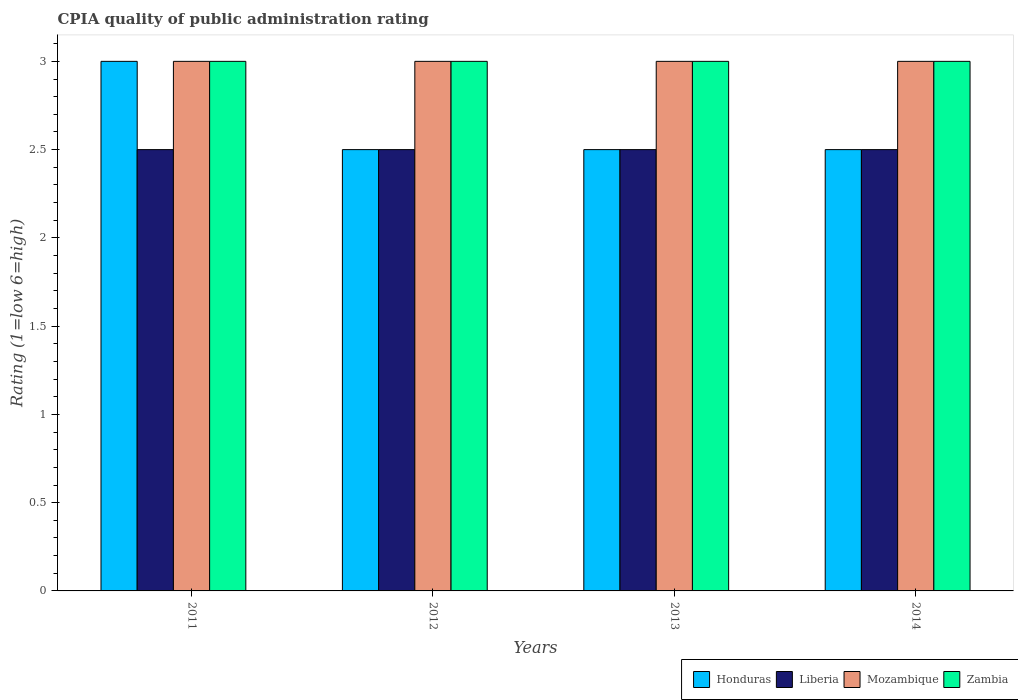How many groups of bars are there?
Your answer should be very brief. 4. Are the number of bars per tick equal to the number of legend labels?
Your answer should be compact. Yes. How many bars are there on the 1st tick from the right?
Your response must be concise. 4. What is the label of the 4th group of bars from the left?
Give a very brief answer. 2014. Across all years, what is the maximum CPIA rating in Honduras?
Provide a succinct answer. 3. Across all years, what is the minimum CPIA rating in Zambia?
Your response must be concise. 3. In which year was the CPIA rating in Liberia maximum?
Ensure brevity in your answer.  2011. In which year was the CPIA rating in Mozambique minimum?
Offer a very short reply. 2011. What is the total CPIA rating in Zambia in the graph?
Give a very brief answer. 12. What is the difference between the CPIA rating in Liberia in 2012 and that in 2014?
Offer a very short reply. 0. What is the difference between the CPIA rating in Honduras in 2014 and the CPIA rating in Mozambique in 2012?
Your answer should be very brief. -0.5. In how many years, is the CPIA rating in Mozambique greater than 2.9?
Ensure brevity in your answer.  4. Is the difference between the CPIA rating in Honduras in 2012 and 2013 greater than the difference between the CPIA rating in Liberia in 2012 and 2013?
Your response must be concise. No. What is the difference between the highest and the second highest CPIA rating in Honduras?
Your response must be concise. 0.5. What is the difference between the highest and the lowest CPIA rating in Zambia?
Provide a short and direct response. 0. In how many years, is the CPIA rating in Liberia greater than the average CPIA rating in Liberia taken over all years?
Your response must be concise. 0. Is it the case that in every year, the sum of the CPIA rating in Liberia and CPIA rating in Zambia is greater than the sum of CPIA rating in Mozambique and CPIA rating in Honduras?
Your answer should be compact. Yes. What does the 2nd bar from the left in 2014 represents?
Your response must be concise. Liberia. What does the 2nd bar from the right in 2011 represents?
Your answer should be very brief. Mozambique. How many bars are there?
Your answer should be compact. 16. How many years are there in the graph?
Provide a succinct answer. 4. What is the difference between two consecutive major ticks on the Y-axis?
Offer a very short reply. 0.5. Does the graph contain any zero values?
Your answer should be very brief. No. Does the graph contain grids?
Make the answer very short. No. Where does the legend appear in the graph?
Make the answer very short. Bottom right. How many legend labels are there?
Your response must be concise. 4. What is the title of the graph?
Your answer should be compact. CPIA quality of public administration rating. Does "Monaco" appear as one of the legend labels in the graph?
Offer a terse response. No. What is the label or title of the X-axis?
Provide a short and direct response. Years. What is the label or title of the Y-axis?
Your answer should be very brief. Rating (1=low 6=high). What is the Rating (1=low 6=high) of Honduras in 2011?
Offer a very short reply. 3. What is the Rating (1=low 6=high) of Mozambique in 2011?
Offer a terse response. 3. What is the Rating (1=low 6=high) of Zambia in 2011?
Make the answer very short. 3. What is the Rating (1=low 6=high) in Honduras in 2012?
Give a very brief answer. 2.5. What is the Rating (1=low 6=high) in Liberia in 2012?
Your answer should be compact. 2.5. What is the Rating (1=low 6=high) of Mozambique in 2012?
Ensure brevity in your answer.  3. What is the Rating (1=low 6=high) in Mozambique in 2013?
Give a very brief answer. 3. What is the Rating (1=low 6=high) of Zambia in 2013?
Provide a short and direct response. 3. What is the Rating (1=low 6=high) in Honduras in 2014?
Provide a short and direct response. 2.5. What is the Rating (1=low 6=high) of Zambia in 2014?
Your answer should be compact. 3. Across all years, what is the maximum Rating (1=low 6=high) of Honduras?
Your response must be concise. 3. Across all years, what is the maximum Rating (1=low 6=high) in Liberia?
Offer a terse response. 2.5. Across all years, what is the maximum Rating (1=low 6=high) in Mozambique?
Your response must be concise. 3. Across all years, what is the minimum Rating (1=low 6=high) of Honduras?
Make the answer very short. 2.5. Across all years, what is the minimum Rating (1=low 6=high) of Liberia?
Offer a very short reply. 2.5. What is the total Rating (1=low 6=high) in Honduras in the graph?
Offer a very short reply. 10.5. What is the total Rating (1=low 6=high) of Zambia in the graph?
Your response must be concise. 12. What is the difference between the Rating (1=low 6=high) of Mozambique in 2011 and that in 2012?
Provide a succinct answer. 0. What is the difference between the Rating (1=low 6=high) in Honduras in 2011 and that in 2013?
Ensure brevity in your answer.  0.5. What is the difference between the Rating (1=low 6=high) in Mozambique in 2011 and that in 2013?
Offer a terse response. 0. What is the difference between the Rating (1=low 6=high) of Honduras in 2011 and that in 2014?
Your response must be concise. 0.5. What is the difference between the Rating (1=low 6=high) of Liberia in 2011 and that in 2014?
Your answer should be compact. 0. What is the difference between the Rating (1=low 6=high) in Mozambique in 2011 and that in 2014?
Your response must be concise. 0. What is the difference between the Rating (1=low 6=high) in Zambia in 2011 and that in 2014?
Give a very brief answer. 0. What is the difference between the Rating (1=low 6=high) of Zambia in 2012 and that in 2013?
Give a very brief answer. 0. What is the difference between the Rating (1=low 6=high) in Honduras in 2012 and that in 2014?
Provide a succinct answer. 0. What is the difference between the Rating (1=low 6=high) of Liberia in 2012 and that in 2014?
Provide a succinct answer. 0. What is the difference between the Rating (1=low 6=high) in Mozambique in 2012 and that in 2014?
Ensure brevity in your answer.  0. What is the difference between the Rating (1=low 6=high) in Liberia in 2013 and that in 2014?
Your answer should be compact. 0. What is the difference between the Rating (1=low 6=high) of Zambia in 2013 and that in 2014?
Ensure brevity in your answer.  0. What is the difference between the Rating (1=low 6=high) of Honduras in 2011 and the Rating (1=low 6=high) of Mozambique in 2012?
Keep it short and to the point. 0. What is the difference between the Rating (1=low 6=high) in Liberia in 2011 and the Rating (1=low 6=high) in Zambia in 2012?
Give a very brief answer. -0.5. What is the difference between the Rating (1=low 6=high) in Mozambique in 2011 and the Rating (1=low 6=high) in Zambia in 2012?
Offer a terse response. 0. What is the difference between the Rating (1=low 6=high) in Liberia in 2011 and the Rating (1=low 6=high) in Mozambique in 2013?
Provide a succinct answer. -0.5. What is the difference between the Rating (1=low 6=high) in Liberia in 2011 and the Rating (1=low 6=high) in Zambia in 2013?
Offer a very short reply. -0.5. What is the difference between the Rating (1=low 6=high) in Honduras in 2011 and the Rating (1=low 6=high) in Liberia in 2014?
Offer a very short reply. 0.5. What is the difference between the Rating (1=low 6=high) of Liberia in 2011 and the Rating (1=low 6=high) of Zambia in 2014?
Give a very brief answer. -0.5. What is the difference between the Rating (1=low 6=high) of Honduras in 2012 and the Rating (1=low 6=high) of Liberia in 2013?
Keep it short and to the point. 0. What is the difference between the Rating (1=low 6=high) of Liberia in 2012 and the Rating (1=low 6=high) of Mozambique in 2013?
Your response must be concise. -0.5. What is the difference between the Rating (1=low 6=high) in Liberia in 2012 and the Rating (1=low 6=high) in Zambia in 2013?
Provide a short and direct response. -0.5. What is the difference between the Rating (1=low 6=high) in Honduras in 2012 and the Rating (1=low 6=high) in Mozambique in 2014?
Ensure brevity in your answer.  -0.5. What is the difference between the Rating (1=low 6=high) in Liberia in 2012 and the Rating (1=low 6=high) in Zambia in 2014?
Keep it short and to the point. -0.5. What is the difference between the Rating (1=low 6=high) of Mozambique in 2012 and the Rating (1=low 6=high) of Zambia in 2014?
Ensure brevity in your answer.  0. What is the difference between the Rating (1=low 6=high) of Honduras in 2013 and the Rating (1=low 6=high) of Liberia in 2014?
Offer a terse response. 0. What is the difference between the Rating (1=low 6=high) of Honduras in 2013 and the Rating (1=low 6=high) of Mozambique in 2014?
Provide a succinct answer. -0.5. What is the difference between the Rating (1=low 6=high) of Honduras in 2013 and the Rating (1=low 6=high) of Zambia in 2014?
Ensure brevity in your answer.  -0.5. What is the difference between the Rating (1=low 6=high) of Liberia in 2013 and the Rating (1=low 6=high) of Zambia in 2014?
Give a very brief answer. -0.5. What is the difference between the Rating (1=low 6=high) of Mozambique in 2013 and the Rating (1=low 6=high) of Zambia in 2014?
Offer a very short reply. 0. What is the average Rating (1=low 6=high) in Honduras per year?
Provide a short and direct response. 2.62. What is the average Rating (1=low 6=high) in Liberia per year?
Your response must be concise. 2.5. What is the average Rating (1=low 6=high) in Zambia per year?
Your response must be concise. 3. In the year 2011, what is the difference between the Rating (1=low 6=high) in Honduras and Rating (1=low 6=high) in Liberia?
Give a very brief answer. 0.5. In the year 2011, what is the difference between the Rating (1=low 6=high) in Liberia and Rating (1=low 6=high) in Zambia?
Your response must be concise. -0.5. In the year 2011, what is the difference between the Rating (1=low 6=high) of Mozambique and Rating (1=low 6=high) of Zambia?
Provide a succinct answer. 0. In the year 2012, what is the difference between the Rating (1=low 6=high) in Liberia and Rating (1=low 6=high) in Mozambique?
Your answer should be compact. -0.5. In the year 2012, what is the difference between the Rating (1=low 6=high) in Liberia and Rating (1=low 6=high) in Zambia?
Your response must be concise. -0.5. In the year 2012, what is the difference between the Rating (1=low 6=high) of Mozambique and Rating (1=low 6=high) of Zambia?
Offer a terse response. 0. In the year 2013, what is the difference between the Rating (1=low 6=high) in Honduras and Rating (1=low 6=high) in Mozambique?
Your answer should be very brief. -0.5. In the year 2013, what is the difference between the Rating (1=low 6=high) in Liberia and Rating (1=low 6=high) in Zambia?
Provide a succinct answer. -0.5. In the year 2013, what is the difference between the Rating (1=low 6=high) in Mozambique and Rating (1=low 6=high) in Zambia?
Ensure brevity in your answer.  0. What is the ratio of the Rating (1=low 6=high) in Zambia in 2011 to that in 2012?
Provide a succinct answer. 1. What is the ratio of the Rating (1=low 6=high) of Mozambique in 2011 to that in 2013?
Your answer should be very brief. 1. What is the ratio of the Rating (1=low 6=high) of Honduras in 2011 to that in 2014?
Your answer should be very brief. 1.2. What is the ratio of the Rating (1=low 6=high) of Honduras in 2012 to that in 2013?
Your answer should be compact. 1. What is the ratio of the Rating (1=low 6=high) of Mozambique in 2012 to that in 2013?
Give a very brief answer. 1. What is the ratio of the Rating (1=low 6=high) of Zambia in 2012 to that in 2013?
Your response must be concise. 1. What is the ratio of the Rating (1=low 6=high) in Honduras in 2012 to that in 2014?
Your answer should be very brief. 1. What is the ratio of the Rating (1=low 6=high) of Mozambique in 2012 to that in 2014?
Offer a very short reply. 1. What is the ratio of the Rating (1=low 6=high) in Zambia in 2012 to that in 2014?
Your answer should be very brief. 1. What is the ratio of the Rating (1=low 6=high) in Honduras in 2013 to that in 2014?
Your answer should be very brief. 1. What is the ratio of the Rating (1=low 6=high) in Mozambique in 2013 to that in 2014?
Your answer should be very brief. 1. What is the ratio of the Rating (1=low 6=high) of Zambia in 2013 to that in 2014?
Provide a succinct answer. 1. What is the difference between the highest and the second highest Rating (1=low 6=high) of Mozambique?
Provide a succinct answer. 0. What is the difference between the highest and the second highest Rating (1=low 6=high) in Zambia?
Your response must be concise. 0. What is the difference between the highest and the lowest Rating (1=low 6=high) in Liberia?
Your answer should be very brief. 0. What is the difference between the highest and the lowest Rating (1=low 6=high) of Zambia?
Your answer should be compact. 0. 